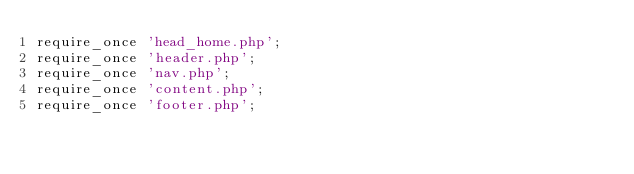Convert code to text. <code><loc_0><loc_0><loc_500><loc_500><_PHP_>require_once 'head_home.php';
require_once 'header.php';
require_once 'nav.php';
require_once 'content.php';
require_once 'footer.php';</code> 